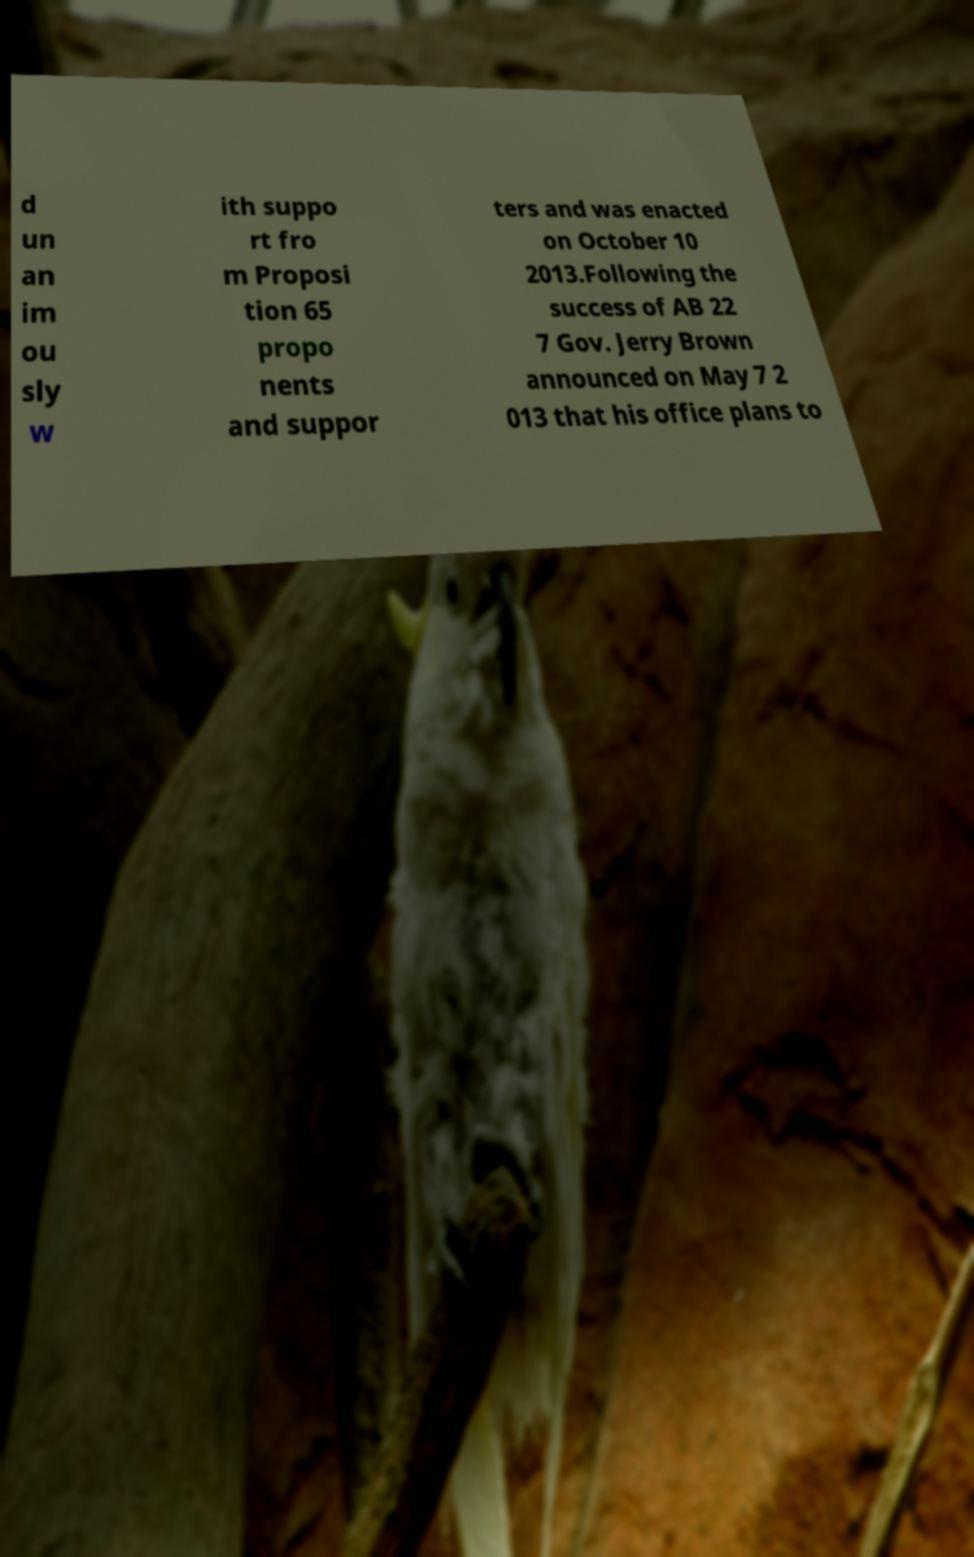For documentation purposes, I need the text within this image transcribed. Could you provide that? d un an im ou sly w ith suppo rt fro m Proposi tion 65 propo nents and suppor ters and was enacted on October 10 2013.Following the success of AB 22 7 Gov. Jerry Brown announced on May 7 2 013 that his office plans to 